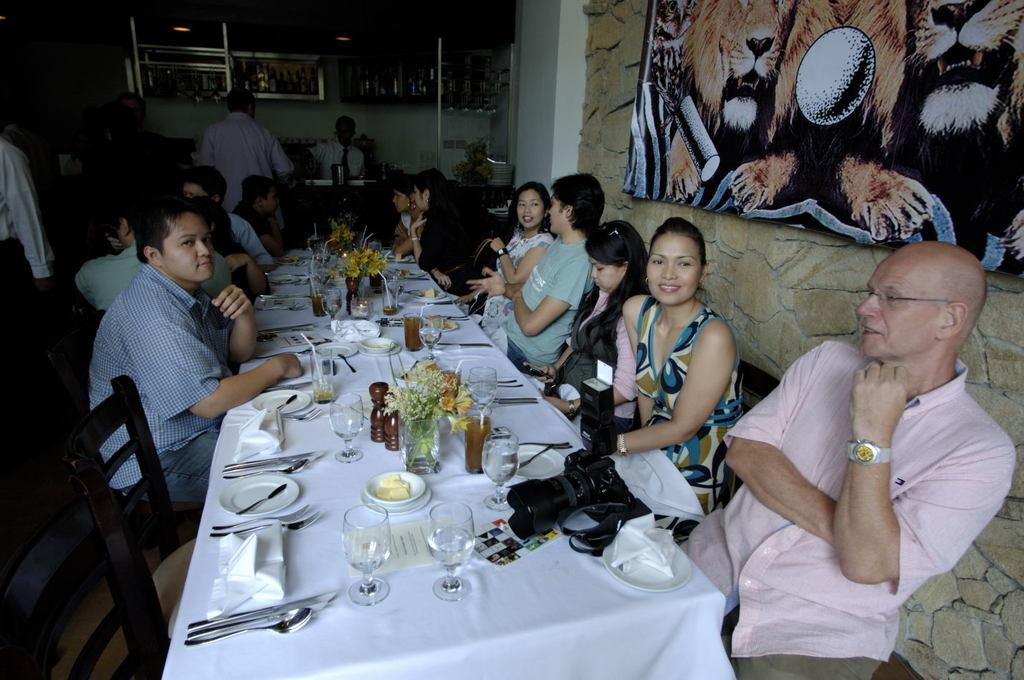What are the people in the image doing? People are seated around the table in the image. What object can be seen on the table? There is a camera, glasses, spoons, knives, a cloth, and plates on the table. What is the purpose of the camera on the table? The purpose of the camera is not specified in the image, but it could be used for taking photos or recording videos. What is covering the table? A cloth is covering the table. What is hanging on the wall behind the people? There is a photo frame on the wall. What type of chess piece is located on the table? There is no chess piece present on the table in the image. How many muscles can be seen flexing in the image? There are no muscles visible in the image; it features people seated around a table with various objects. 